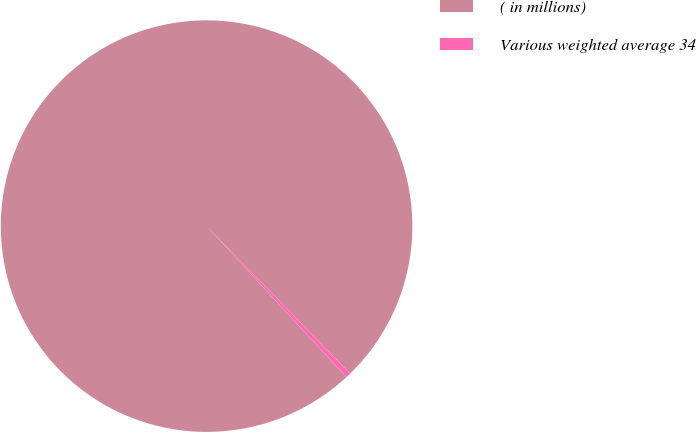<chart> <loc_0><loc_0><loc_500><loc_500><pie_chart><fcel>( in millions)<fcel>Various weighted average 34<nl><fcel>99.6%<fcel>0.4%<nl></chart> 